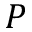<formula> <loc_0><loc_0><loc_500><loc_500>P</formula> 